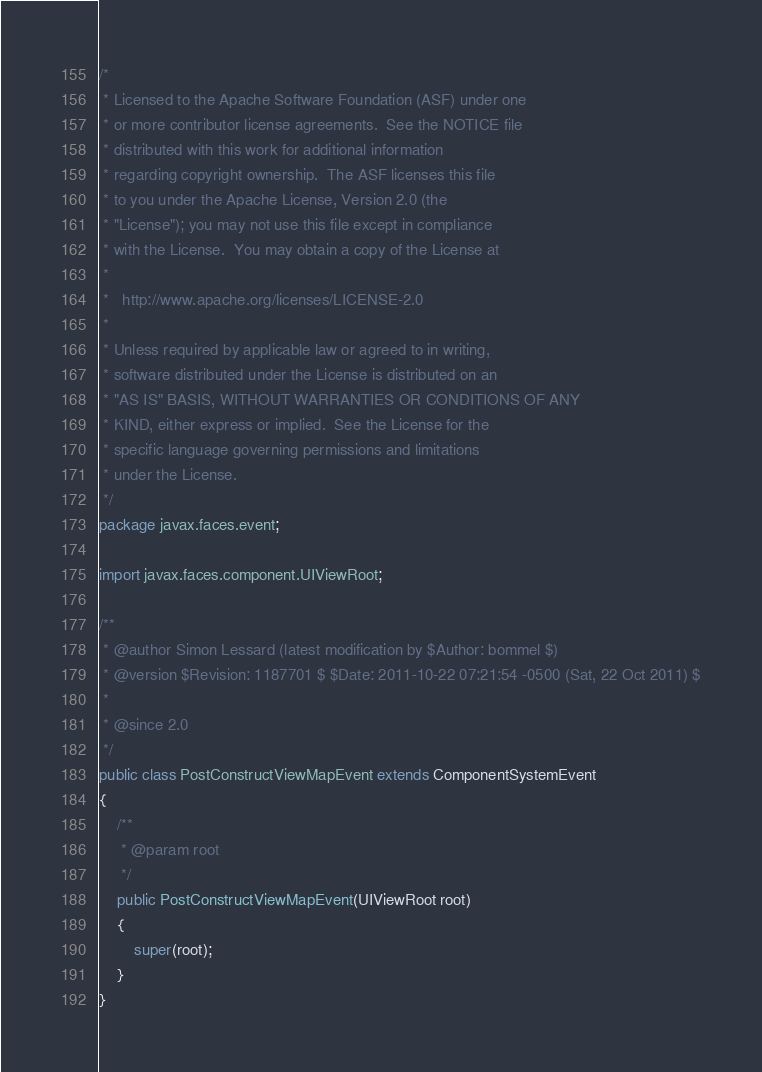<code> <loc_0><loc_0><loc_500><loc_500><_Java_>/*
 * Licensed to the Apache Software Foundation (ASF) under one
 * or more contributor license agreements.  See the NOTICE file
 * distributed with this work for additional information
 * regarding copyright ownership.  The ASF licenses this file
 * to you under the Apache License, Version 2.0 (the
 * "License"); you may not use this file except in compliance
 * with the License.  You may obtain a copy of the License at
 *
 *   http://www.apache.org/licenses/LICENSE-2.0
 *
 * Unless required by applicable law or agreed to in writing,
 * software distributed under the License is distributed on an
 * "AS IS" BASIS, WITHOUT WARRANTIES OR CONDITIONS OF ANY
 * KIND, either express or implied.  See the License for the
 * specific language governing permissions and limitations
 * under the License.
 */
package javax.faces.event;

import javax.faces.component.UIViewRoot;

/**
 * @author Simon Lessard (latest modification by $Author: bommel $)
 * @version $Revision: 1187701 $ $Date: 2011-10-22 07:21:54 -0500 (Sat, 22 Oct 2011) $
 * 
 * @since 2.0
 */
public class PostConstructViewMapEvent extends ComponentSystemEvent
{
    /**
     * @param root
     */
    public PostConstructViewMapEvent(UIViewRoot root)
    {
        super(root);
    }
}
</code> 